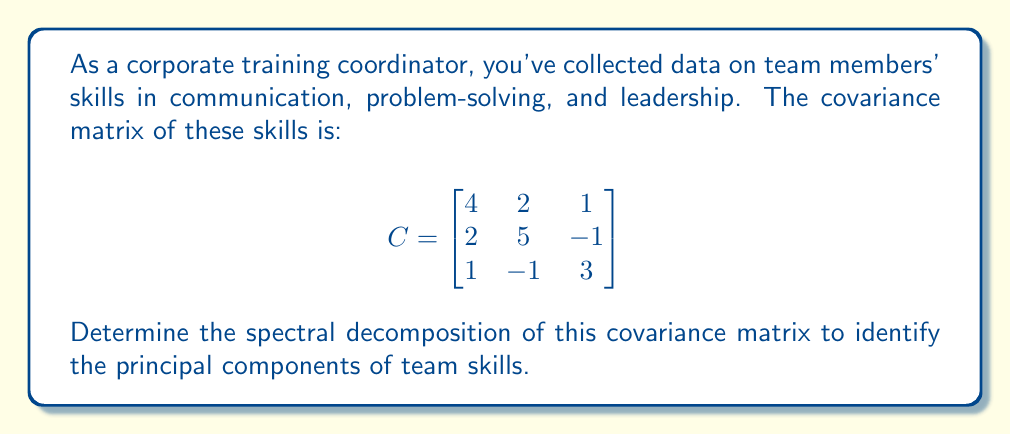Give your solution to this math problem. To find the spectral decomposition of the covariance matrix C, we need to follow these steps:

1) Find the eigenvalues of C by solving the characteristic equation:
   $$det(C - \lambda I) = 0$$
   
   $$\begin{vmatrix}
   4-\lambda & 2 & 1 \\
   2 & 5-\lambda & -1 \\
   1 & -1 & 3-\lambda
   \end{vmatrix} = 0$$

2) Expanding the determinant:
   $$-\lambda^3 + 12\lambda^2 - 41\lambda + 40 = 0$$

3) Solving this equation (using a calculator or computer algebra system), we get:
   $$\lambda_1 = 7, \lambda_2 = 4, \lambda_3 = 1$$

4) For each eigenvalue, find the corresponding eigenvector by solving:
   $$(C - \lambda_i I)v_i = 0$$

5) For $\lambda_1 = 7$:
   $$\begin{bmatrix}
   -3 & 2 & 1 \\
   2 & -2 & -1 \\
   1 & -1 & -4
   \end{bmatrix}v_1 = 0$$
   
   Solving this, we get: $v_1 = (2, 2, 1)^T$

6) Similarly, for $\lambda_2 = 4$ and $\lambda_3 = 1$, we get:
   $v_2 = (-1, 1, 1)^T$ and $v_3 = (1, -1, 2)^T$

7) Normalize these eigenvectors:
   $$u_1 = \frac{1}{\sqrt{9}}(2, 2, 1)^T = \frac{1}{3}(2, 2, 1)^T$$
   $$u_2 = \frac{1}{\sqrt{3}}(-1, 1, 1)^T$$
   $$u_3 = \frac{1}{\sqrt{6}}(1, -1, 2)^T$$

8) The spectral decomposition is:
   $$C = U\Lambda U^T$$
   
   Where $U = [u_1 | u_2 | u_3]$ and $\Lambda = diag(7, 4, 1)$
Answer: $C = U\Lambda U^T$, where $U = [\frac{1}{3}(2, 2, 1)^T | \frac{1}{\sqrt{3}}(-1, 1, 1)^T | \frac{1}{\sqrt{6}}(1, -1, 2)^T]$ and $\Lambda = diag(7, 4, 1)$ 